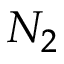<formula> <loc_0><loc_0><loc_500><loc_500>N _ { 2 }</formula> 